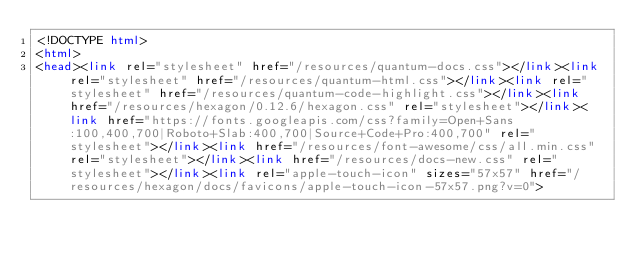Convert code to text. <code><loc_0><loc_0><loc_500><loc_500><_HTML_><!DOCTYPE html>
<html>
<head><link rel="stylesheet" href="/resources/quantum-docs.css"></link><link rel="stylesheet" href="/resources/quantum-html.css"></link><link rel="stylesheet" href="/resources/quantum-code-highlight.css"></link><link href="/resources/hexagon/0.12.6/hexagon.css" rel="stylesheet"></link><link href="https://fonts.googleapis.com/css?family=Open+Sans:100,400,700|Roboto+Slab:400,700|Source+Code+Pro:400,700" rel="stylesheet"></link><link href="/resources/font-awesome/css/all.min.css" rel="stylesheet"></link><link href="/resources/docs-new.css" rel="stylesheet"></link><link rel="apple-touch-icon" sizes="57x57" href="/resources/hexagon/docs/favicons/apple-touch-icon-57x57.png?v=0"></code> 